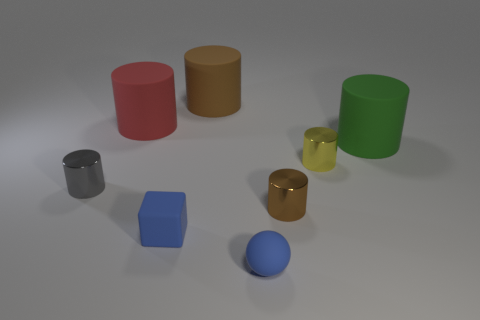There is a brown thing that is the same size as the green cylinder; what is its shape?
Offer a terse response. Cylinder. What number of other things are the same color as the tiny rubber ball?
Make the answer very short. 1. There is a object that is both behind the yellow thing and on the right side of the tiny brown cylinder; what shape is it?
Offer a terse response. Cylinder. Are there any tiny matte cubes behind the matte cylinder that is left of the brown object that is behind the big green object?
Keep it short and to the point. No. How many other things are the same material as the big green thing?
Your answer should be very brief. 4. How many yellow metallic objects are there?
Offer a very short reply. 1. How many things are either small blue metallic things or rubber objects on the right side of the small yellow metallic cylinder?
Offer a very short reply. 1. Is there anything else that is the same shape as the yellow shiny thing?
Your response must be concise. Yes. There is a rubber cylinder right of the sphere; is it the same size as the small gray shiny cylinder?
Give a very brief answer. No. What number of rubber objects are large objects or cylinders?
Provide a succinct answer. 3. 